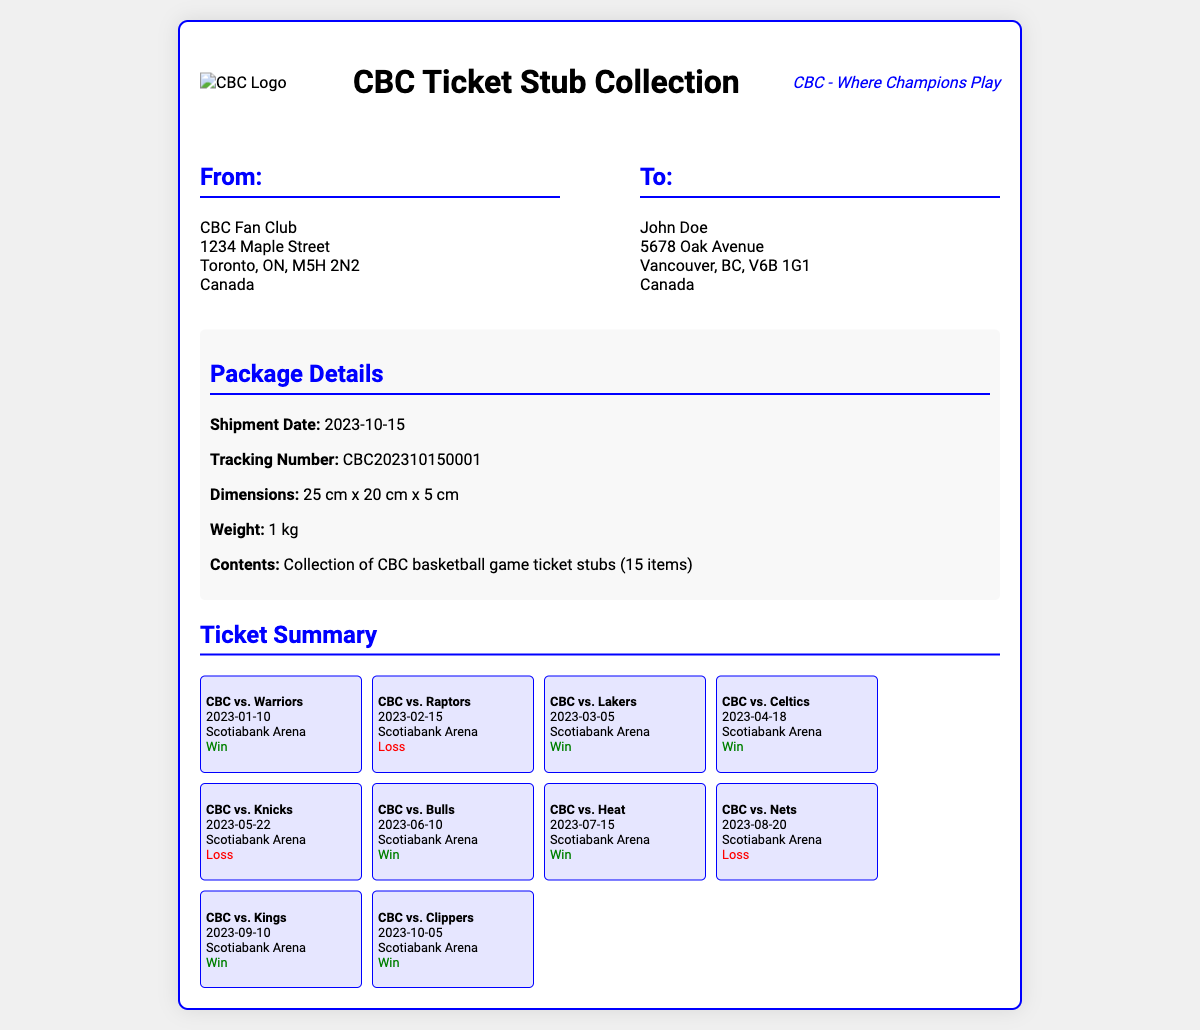What is the shipment date? The shipment date is listed under Package Details in the document.
Answer: 2023-10-15 What is the tracking number? The tracking number can be found in the Package Details section.
Answer: CBC202310150001 What are the package dimensions? The dimensions of the package are mentioned in the Package Details.
Answer: 25 cm x 20 cm x 5 cm Who is the sender? The sender's information is located in the From section of the document.
Answer: CBC Fan Club How many ticket stubs are included in the package? The number of ticket stubs is indicated in the Contents section of Package Details.
Answer: 15 items What is the result of the CBC vs. Warriors game? The game summary for CBC vs. Warriors indicates the result.
Answer: Win Which arena hosted the games? The arena is mentioned in the ticket summaries for each game.
Answer: Scotiabank Arena What is the address of the recipient? The recipient's address can be found in the To section.
Answer: 5678 Oak Avenue, Vancouver, BC, V6B 1G1, Canada What team did CBC lose against on February 15? The result for that game is summarized in the ticket details.
Answer: Raptors 